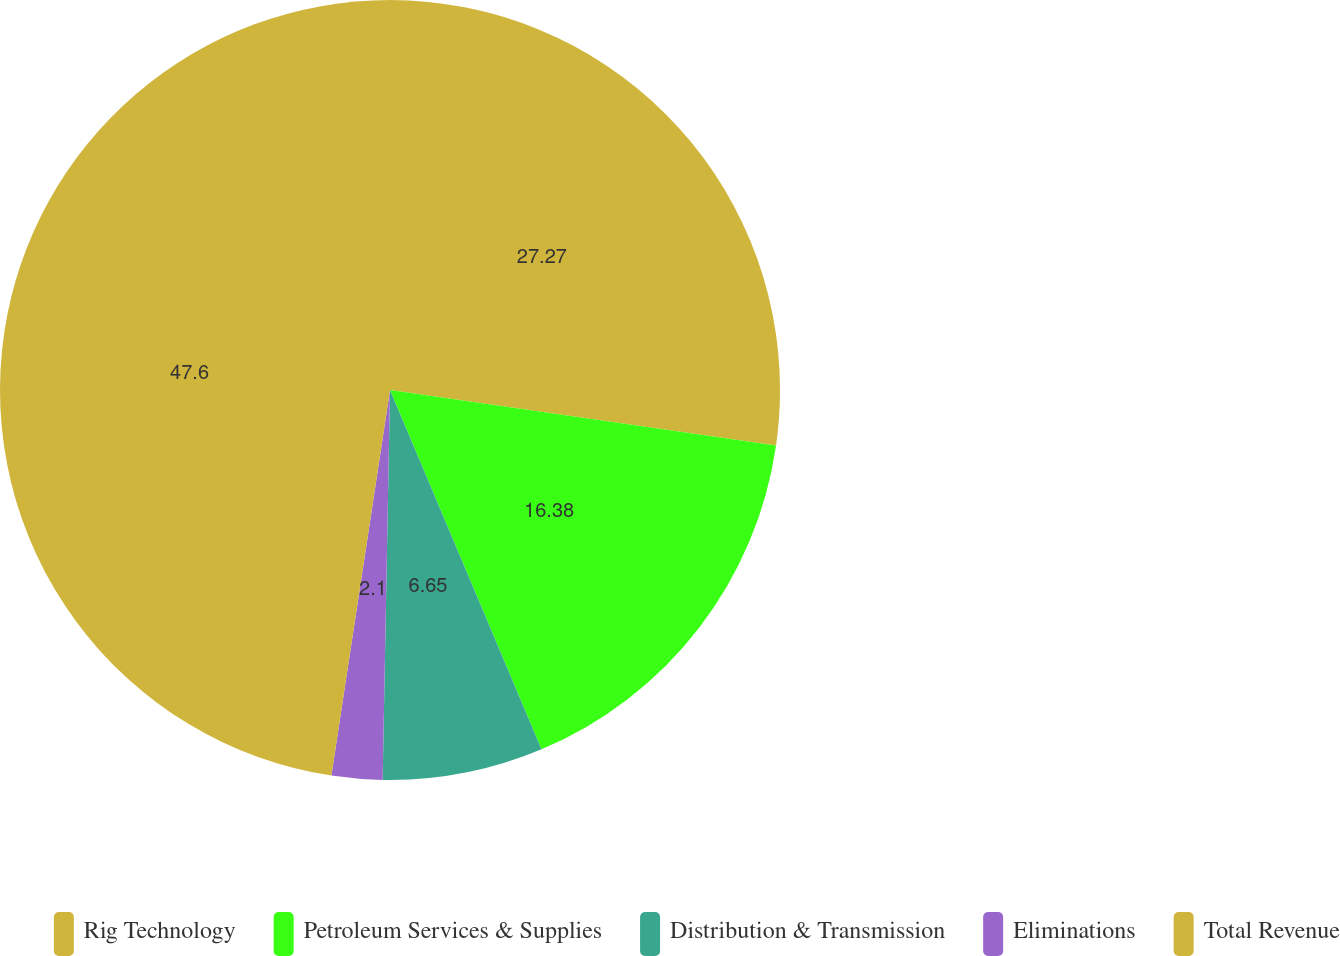Convert chart to OTSL. <chart><loc_0><loc_0><loc_500><loc_500><pie_chart><fcel>Rig Technology<fcel>Petroleum Services & Supplies<fcel>Distribution & Transmission<fcel>Eliminations<fcel>Total Revenue<nl><fcel>27.27%<fcel>16.38%<fcel>6.65%<fcel>2.1%<fcel>47.6%<nl></chart> 